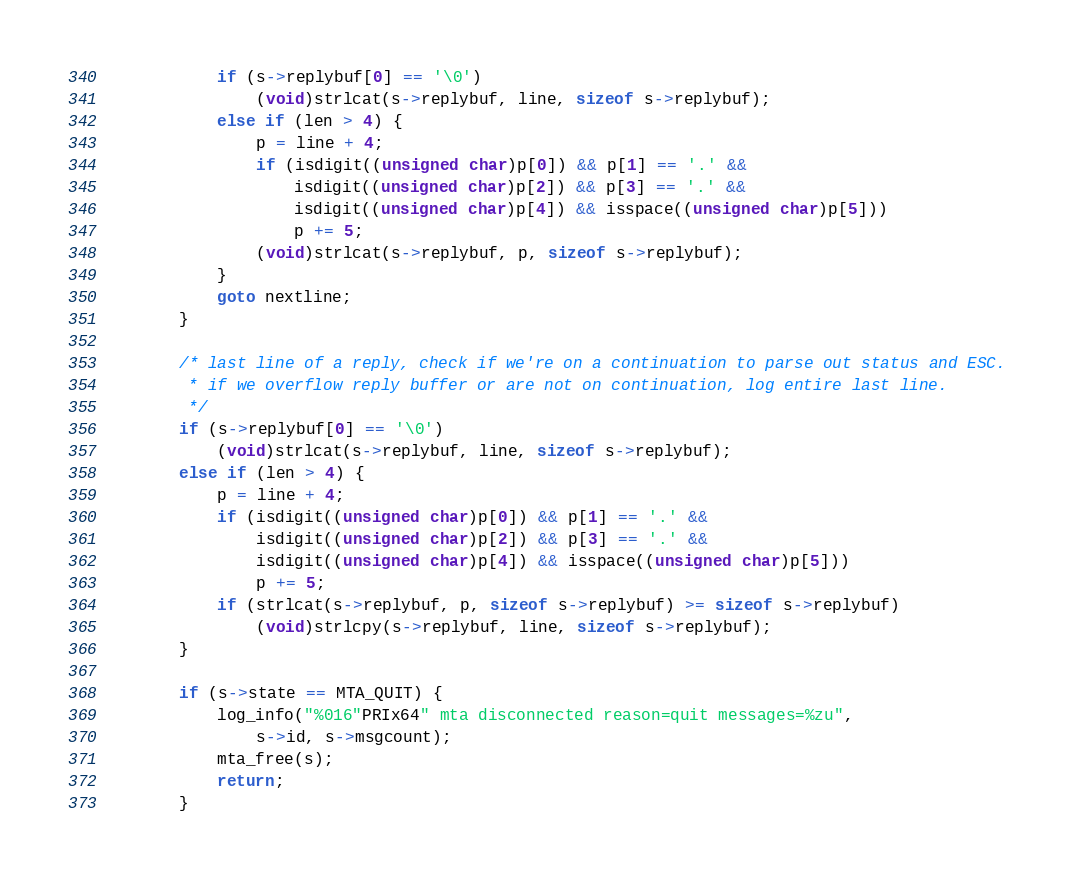<code> <loc_0><loc_0><loc_500><loc_500><_C_>			if (s->replybuf[0] == '\0')
				(void)strlcat(s->replybuf, line, sizeof s->replybuf);
			else if (len > 4) {
				p = line + 4;
				if (isdigit((unsigned char)p[0]) && p[1] == '.' &&
				    isdigit((unsigned char)p[2]) && p[3] == '.' &&
				    isdigit((unsigned char)p[4]) && isspace((unsigned char)p[5]))
					p += 5;
				(void)strlcat(s->replybuf, p, sizeof s->replybuf);
			}
			goto nextline;
		}

		/* last line of a reply, check if we're on a continuation to parse out status and ESC.
		 * if we overflow reply buffer or are not on continuation, log entire last line.
		 */
		if (s->replybuf[0] == '\0')
			(void)strlcat(s->replybuf, line, sizeof s->replybuf);
		else if (len > 4) {
			p = line + 4;
			if (isdigit((unsigned char)p[0]) && p[1] == '.' &&
			    isdigit((unsigned char)p[2]) && p[3] == '.' &&
			    isdigit((unsigned char)p[4]) && isspace((unsigned char)p[5]))
				p += 5;
			if (strlcat(s->replybuf, p, sizeof s->replybuf) >= sizeof s->replybuf)
				(void)strlcpy(s->replybuf, line, sizeof s->replybuf);
		}

		if (s->state == MTA_QUIT) {
			log_info("%016"PRIx64" mta disconnected reason=quit messages=%zu",
			    s->id, s->msgcount);
			mta_free(s);
			return;
		}</code> 